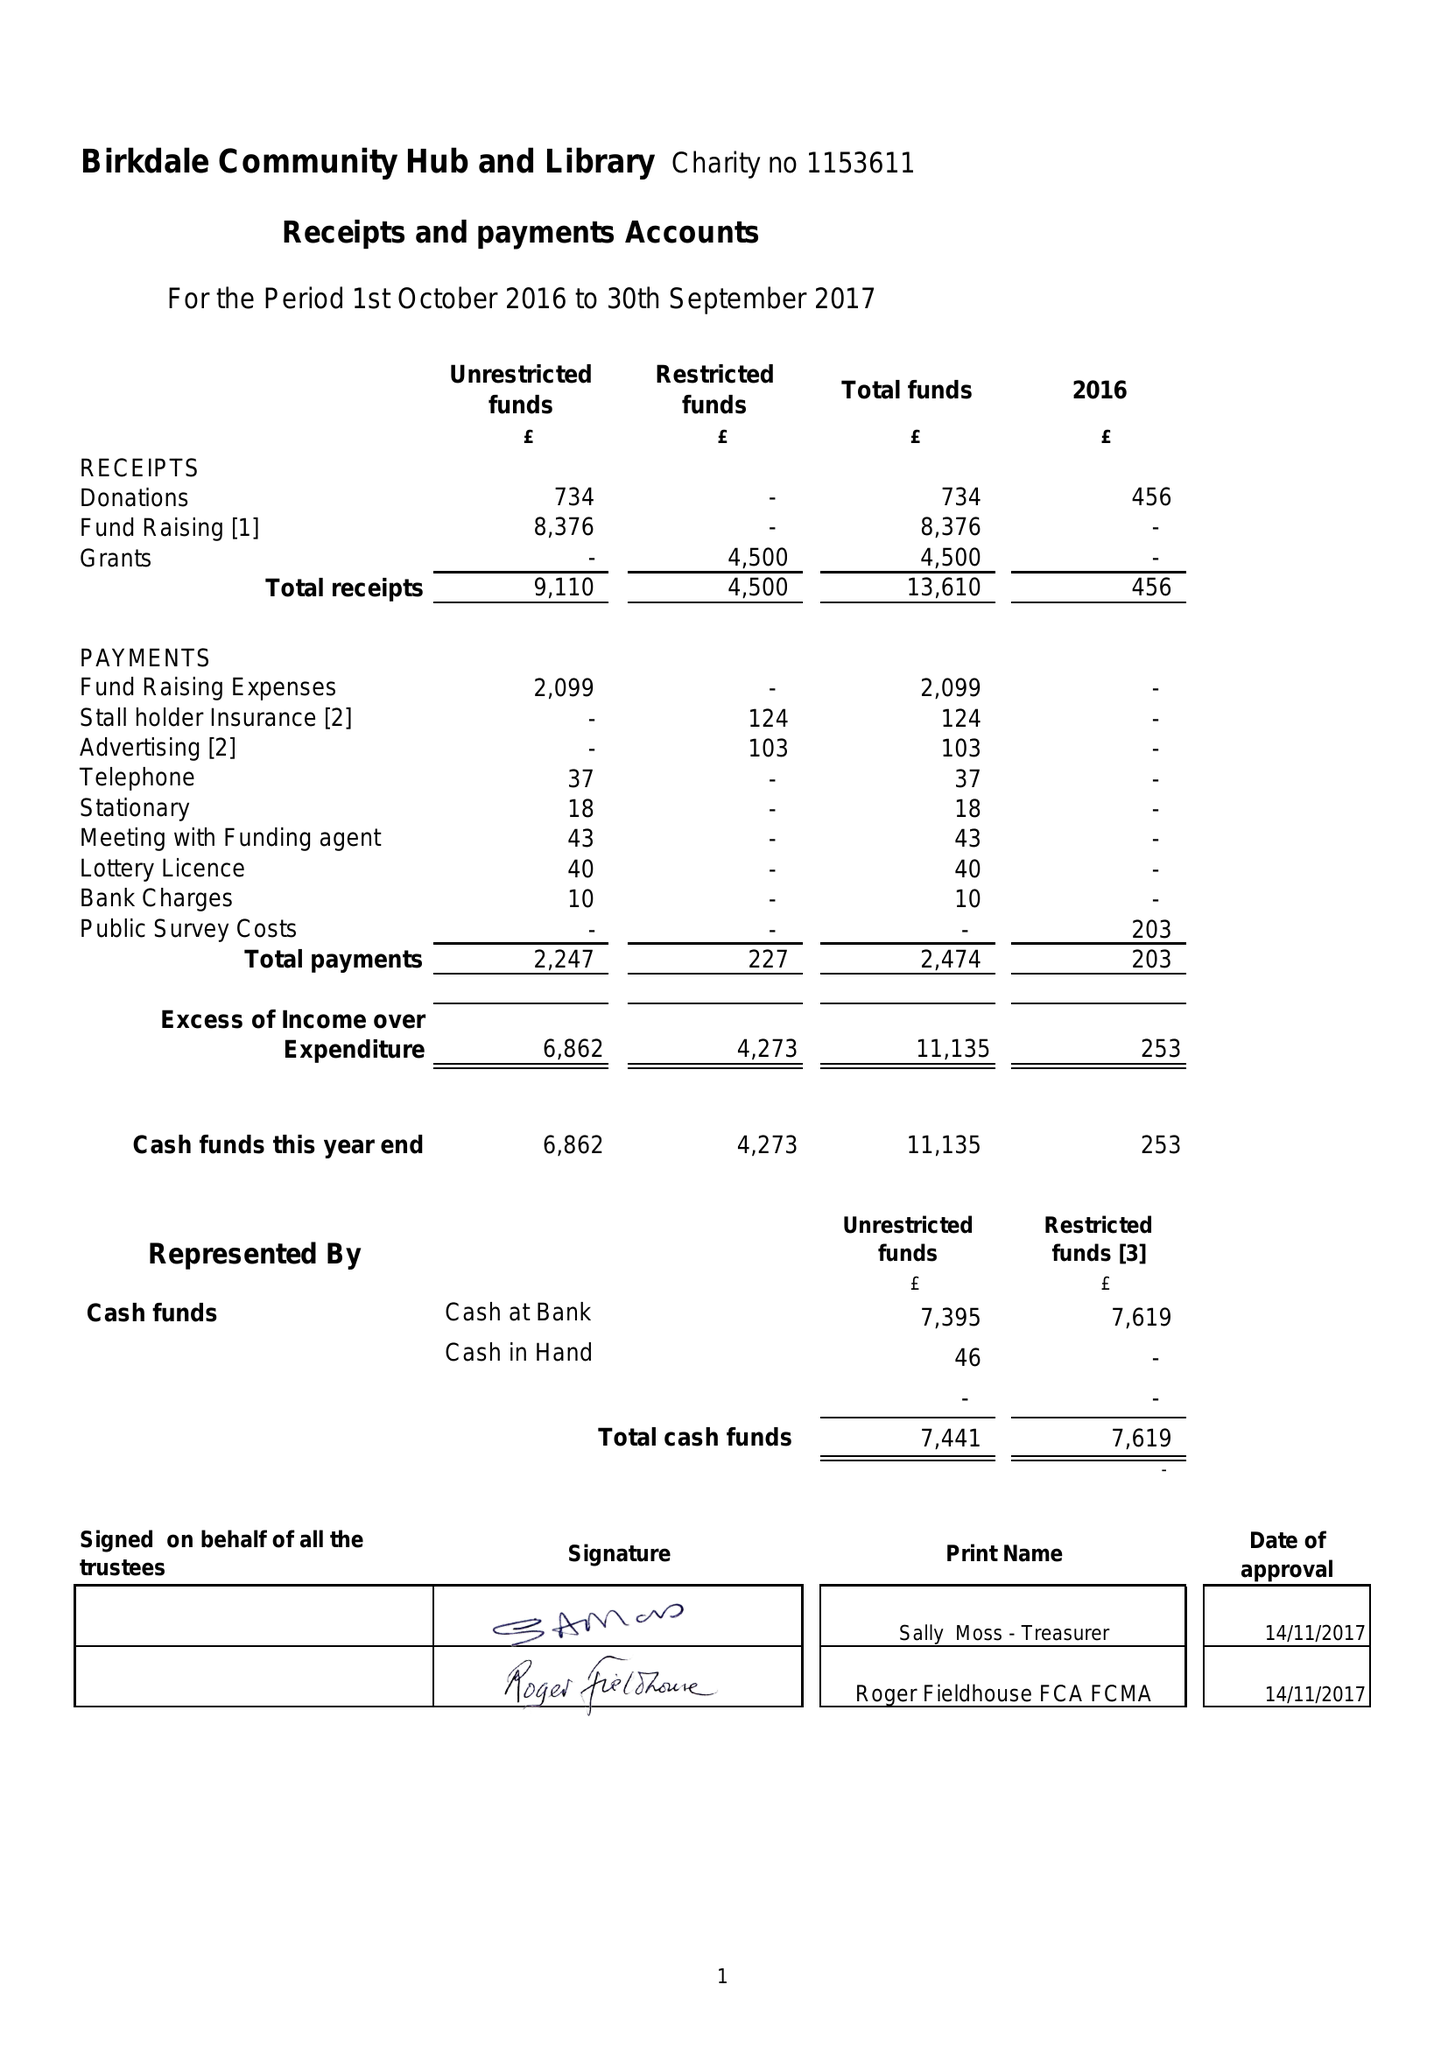What is the value for the address__street_line?
Answer the question using a single word or phrase. None 